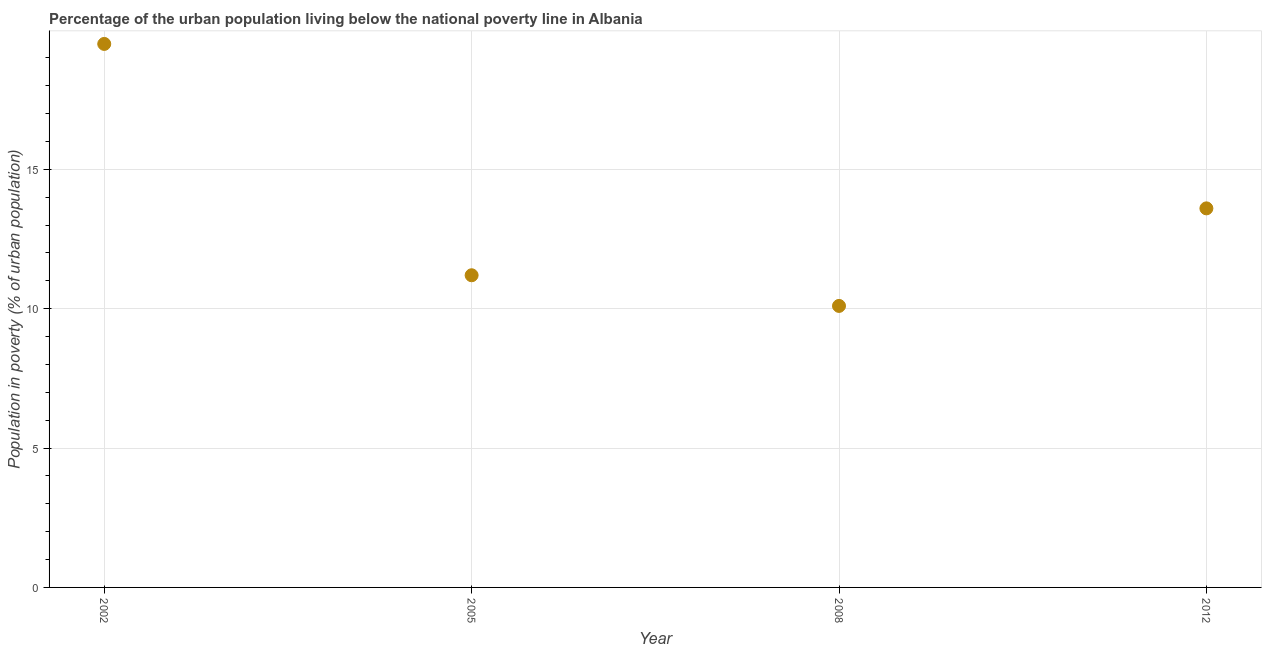In which year was the percentage of urban population living below poverty line maximum?
Your response must be concise. 2002. What is the sum of the percentage of urban population living below poverty line?
Give a very brief answer. 54.4. What is the difference between the percentage of urban population living below poverty line in 2002 and 2005?
Your response must be concise. 8.3. What is the average percentage of urban population living below poverty line per year?
Make the answer very short. 13.6. What is the median percentage of urban population living below poverty line?
Ensure brevity in your answer.  12.4. In how many years, is the percentage of urban population living below poverty line greater than 9 %?
Provide a short and direct response. 4. What is the ratio of the percentage of urban population living below poverty line in 2008 to that in 2012?
Ensure brevity in your answer.  0.74. Is the difference between the percentage of urban population living below poverty line in 2002 and 2008 greater than the difference between any two years?
Provide a succinct answer. Yes. Is the sum of the percentage of urban population living below poverty line in 2002 and 2012 greater than the maximum percentage of urban population living below poverty line across all years?
Keep it short and to the point. Yes. In how many years, is the percentage of urban population living below poverty line greater than the average percentage of urban population living below poverty line taken over all years?
Your answer should be very brief. 1. What is the difference between two consecutive major ticks on the Y-axis?
Your answer should be compact. 5. Are the values on the major ticks of Y-axis written in scientific E-notation?
Provide a short and direct response. No. Does the graph contain any zero values?
Give a very brief answer. No. Does the graph contain grids?
Offer a terse response. Yes. What is the title of the graph?
Provide a short and direct response. Percentage of the urban population living below the national poverty line in Albania. What is the label or title of the Y-axis?
Make the answer very short. Population in poverty (% of urban population). What is the Population in poverty (% of urban population) in 2005?
Provide a succinct answer. 11.2. What is the Population in poverty (% of urban population) in 2008?
Your answer should be very brief. 10.1. What is the difference between the Population in poverty (% of urban population) in 2002 and 2012?
Give a very brief answer. 5.9. What is the difference between the Population in poverty (% of urban population) in 2005 and 2008?
Make the answer very short. 1.1. What is the difference between the Population in poverty (% of urban population) in 2008 and 2012?
Your response must be concise. -3.5. What is the ratio of the Population in poverty (% of urban population) in 2002 to that in 2005?
Your answer should be very brief. 1.74. What is the ratio of the Population in poverty (% of urban population) in 2002 to that in 2008?
Offer a terse response. 1.93. What is the ratio of the Population in poverty (% of urban population) in 2002 to that in 2012?
Your answer should be compact. 1.43. What is the ratio of the Population in poverty (% of urban population) in 2005 to that in 2008?
Provide a succinct answer. 1.11. What is the ratio of the Population in poverty (% of urban population) in 2005 to that in 2012?
Ensure brevity in your answer.  0.82. What is the ratio of the Population in poverty (% of urban population) in 2008 to that in 2012?
Offer a very short reply. 0.74. 